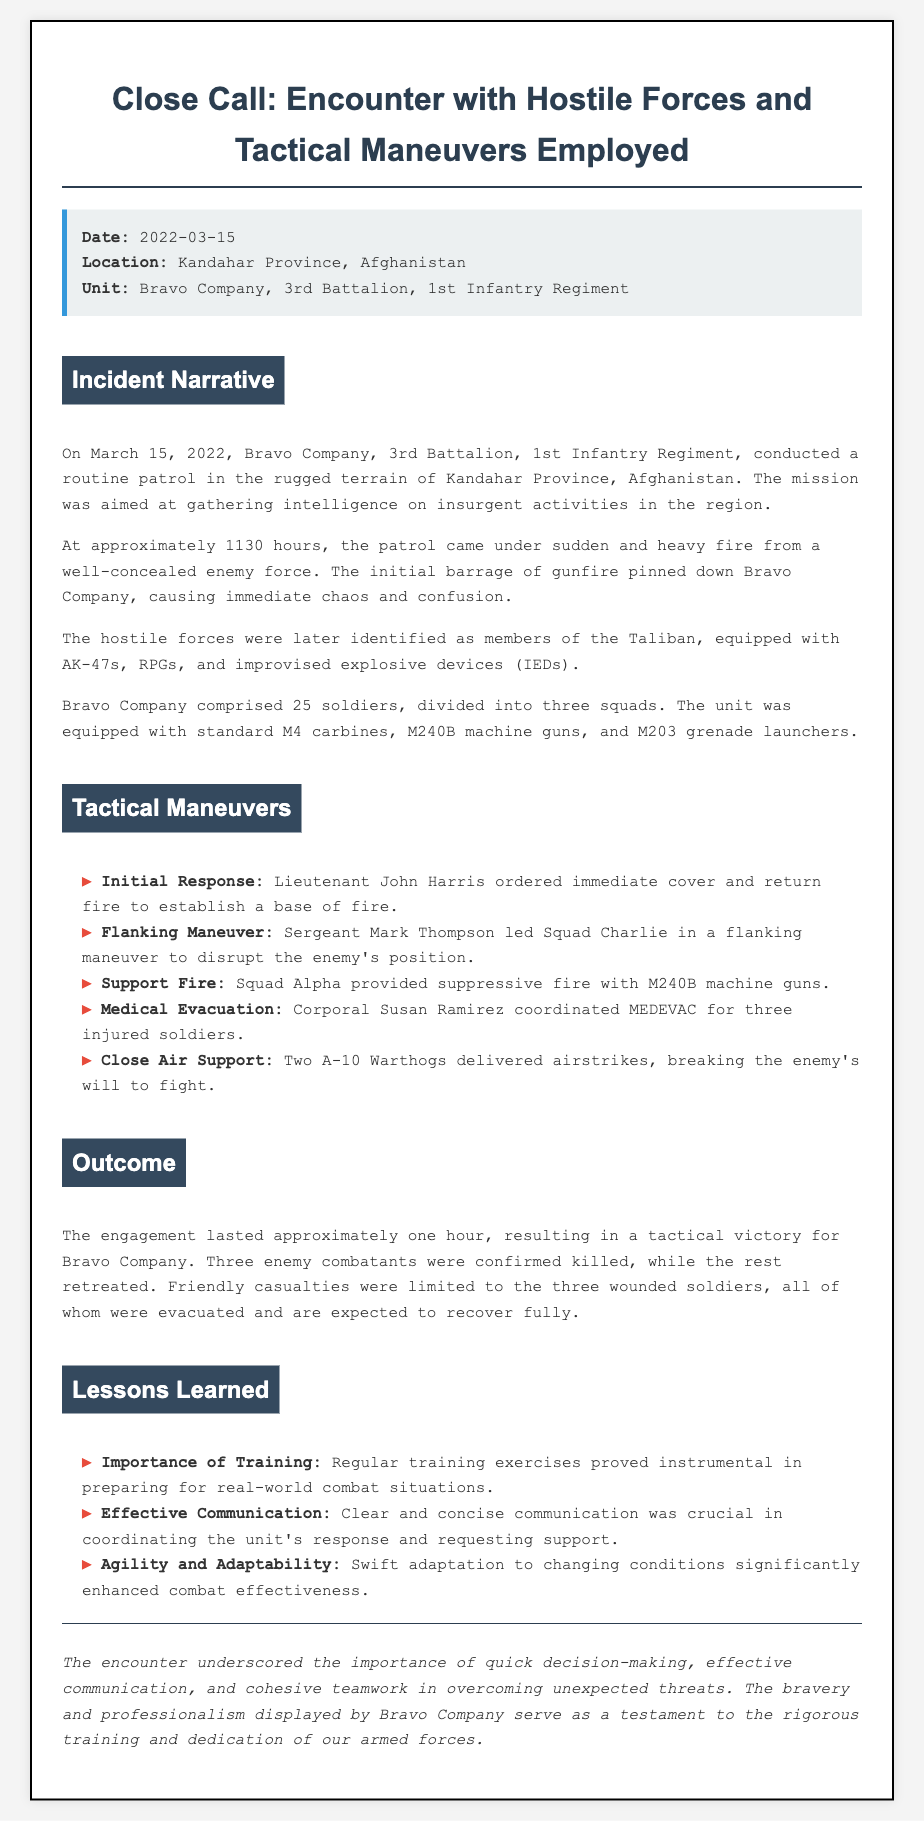What date did the encounter occur? The date of the encounter is mentioned in the report details section, which states it happened on March 15, 2022.
Answer: March 15, 2022 What unit was involved in the incident? The report details specify that Bravo Company, 3rd Battalion, 1st Infantry Regiment was the unit involved.
Answer: Bravo Company, 3rd Battalion, 1st Infantry Regiment How many soldiers were in Bravo Company? The incident narrative states that Bravo Company comprised 25 soldiers.
Answer: 25 soldiers What enemy forces were identified? The narrative identifies the hostile forces as members of the Taliban.
Answer: Taliban Who coordinated the medical evacuation? The tactical maneuvers detail that Corporal Susan Ramirez coordinated the MEDEVAC for injured soldiers.
Answer: Corporal Susan Ramirez What type of aircraft provided close air support? The tactical maneuvers section mentions that two A-10 Warthogs delivered airstrikes for close air support.
Answer: A-10 Warthogs What was the outcome regarding friendly casualties? The outcome section mentions that friendly casualties were limited to three wounded soldiers.
Answer: Three wounded soldiers What is one lesson learned from the engagement? The lessons learned section highlights the importance of training as a key takeaway.
Answer: Importance of Training What tactical maneuver did Sergeant Mark Thompson lead? The tactical maneuvers section states that Sergeant Mark Thompson led a flanking maneuver.
Answer: Flanking Maneuver 